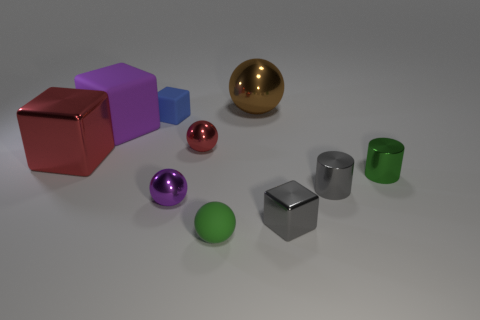How many tiny gray metallic cylinders are right of the brown sphere?
Provide a short and direct response. 1. What is the color of the tiny cube on the right side of the big brown metallic sphere?
Your answer should be compact. Gray. The other rubber object that is the same shape as the blue rubber thing is what color?
Ensure brevity in your answer.  Purple. Is there any other thing of the same color as the big metallic ball?
Offer a terse response. No. Is the number of green spheres greater than the number of yellow cylinders?
Offer a terse response. Yes. Does the blue object have the same material as the tiny green cylinder?
Ensure brevity in your answer.  No. What number of yellow cylinders are made of the same material as the red ball?
Your answer should be compact. 0. There is a green cylinder; is it the same size as the cube that is to the right of the matte ball?
Offer a very short reply. Yes. What is the color of the object that is both on the right side of the tiny green rubber thing and left of the gray cube?
Offer a very short reply. Brown. There is a metal ball in front of the big metal block; is there a gray block that is left of it?
Provide a short and direct response. No. 